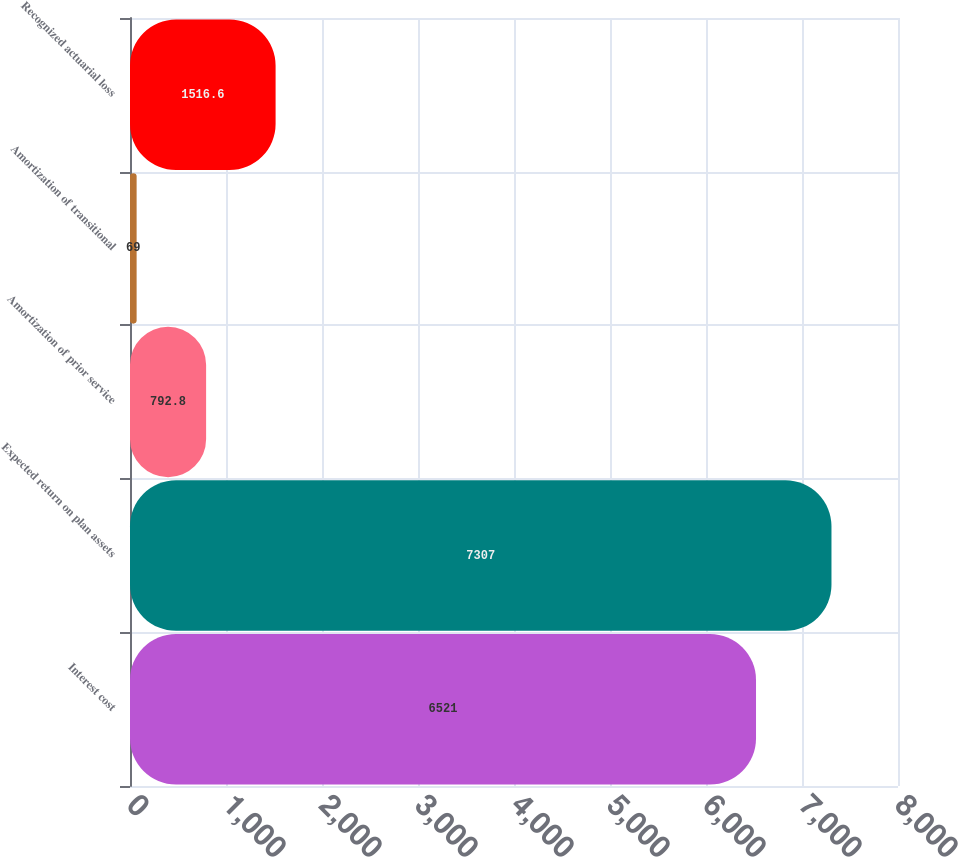Convert chart to OTSL. <chart><loc_0><loc_0><loc_500><loc_500><bar_chart><fcel>Interest cost<fcel>Expected return on plan assets<fcel>Amortization of prior service<fcel>Amortization of transitional<fcel>Recognized actuarial loss<nl><fcel>6521<fcel>7307<fcel>792.8<fcel>69<fcel>1516.6<nl></chart> 